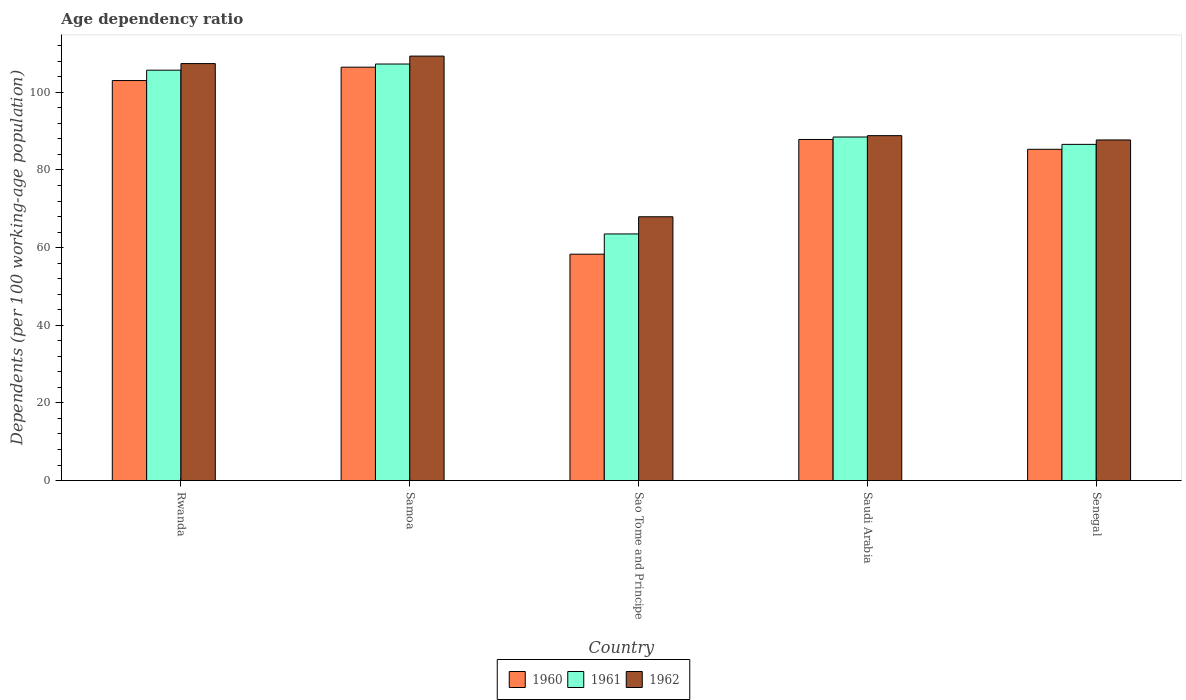How many different coloured bars are there?
Your answer should be very brief. 3. What is the label of the 2nd group of bars from the left?
Provide a succinct answer. Samoa. What is the age dependency ratio in in 1961 in Senegal?
Your answer should be very brief. 86.59. Across all countries, what is the maximum age dependency ratio in in 1960?
Your response must be concise. 106.47. Across all countries, what is the minimum age dependency ratio in in 1961?
Your answer should be compact. 63.52. In which country was the age dependency ratio in in 1961 maximum?
Your answer should be very brief. Samoa. In which country was the age dependency ratio in in 1962 minimum?
Provide a short and direct response. Sao Tome and Principe. What is the total age dependency ratio in in 1961 in the graph?
Keep it short and to the point. 451.57. What is the difference between the age dependency ratio in in 1962 in Saudi Arabia and that in Senegal?
Ensure brevity in your answer.  1.11. What is the difference between the age dependency ratio in in 1962 in Sao Tome and Principe and the age dependency ratio in in 1960 in Samoa?
Provide a succinct answer. -38.53. What is the average age dependency ratio in in 1961 per country?
Offer a very short reply. 90.31. What is the difference between the age dependency ratio in of/in 1962 and age dependency ratio in of/in 1960 in Rwanda?
Provide a succinct answer. 4.37. What is the ratio of the age dependency ratio in in 1962 in Rwanda to that in Saudi Arabia?
Offer a terse response. 1.21. What is the difference between the highest and the second highest age dependency ratio in in 1962?
Keep it short and to the point. -18.56. What is the difference between the highest and the lowest age dependency ratio in in 1962?
Give a very brief answer. 41.38. In how many countries, is the age dependency ratio in in 1962 greater than the average age dependency ratio in in 1962 taken over all countries?
Make the answer very short. 2. How many bars are there?
Your response must be concise. 15. Are all the bars in the graph horizontal?
Your response must be concise. No. How many countries are there in the graph?
Your answer should be compact. 5. Are the values on the major ticks of Y-axis written in scientific E-notation?
Your answer should be very brief. No. Does the graph contain grids?
Offer a very short reply. No. Where does the legend appear in the graph?
Offer a very short reply. Bottom center. How many legend labels are there?
Make the answer very short. 3. What is the title of the graph?
Give a very brief answer. Age dependency ratio. What is the label or title of the X-axis?
Provide a succinct answer. Country. What is the label or title of the Y-axis?
Make the answer very short. Dependents (per 100 working-age population). What is the Dependents (per 100 working-age population) of 1960 in Rwanda?
Provide a succinct answer. 103.02. What is the Dependents (per 100 working-age population) of 1961 in Rwanda?
Provide a succinct answer. 105.69. What is the Dependents (per 100 working-age population) of 1962 in Rwanda?
Provide a short and direct response. 107.39. What is the Dependents (per 100 working-age population) of 1960 in Samoa?
Provide a short and direct response. 106.47. What is the Dependents (per 100 working-age population) of 1961 in Samoa?
Keep it short and to the point. 107.28. What is the Dependents (per 100 working-age population) in 1962 in Samoa?
Ensure brevity in your answer.  109.32. What is the Dependents (per 100 working-age population) in 1960 in Sao Tome and Principe?
Provide a succinct answer. 58.31. What is the Dependents (per 100 working-age population) in 1961 in Sao Tome and Principe?
Give a very brief answer. 63.52. What is the Dependents (per 100 working-age population) of 1962 in Sao Tome and Principe?
Your answer should be very brief. 67.94. What is the Dependents (per 100 working-age population) of 1960 in Saudi Arabia?
Your answer should be very brief. 87.85. What is the Dependents (per 100 working-age population) in 1961 in Saudi Arabia?
Your answer should be compact. 88.48. What is the Dependents (per 100 working-age population) in 1962 in Saudi Arabia?
Your answer should be very brief. 88.83. What is the Dependents (per 100 working-age population) of 1960 in Senegal?
Ensure brevity in your answer.  85.32. What is the Dependents (per 100 working-age population) in 1961 in Senegal?
Keep it short and to the point. 86.59. What is the Dependents (per 100 working-age population) of 1962 in Senegal?
Offer a terse response. 87.72. Across all countries, what is the maximum Dependents (per 100 working-age population) in 1960?
Keep it short and to the point. 106.47. Across all countries, what is the maximum Dependents (per 100 working-age population) in 1961?
Offer a terse response. 107.28. Across all countries, what is the maximum Dependents (per 100 working-age population) in 1962?
Provide a succinct answer. 109.32. Across all countries, what is the minimum Dependents (per 100 working-age population) in 1960?
Keep it short and to the point. 58.31. Across all countries, what is the minimum Dependents (per 100 working-age population) of 1961?
Your response must be concise. 63.52. Across all countries, what is the minimum Dependents (per 100 working-age population) in 1962?
Offer a terse response. 67.94. What is the total Dependents (per 100 working-age population) of 1960 in the graph?
Make the answer very short. 440.96. What is the total Dependents (per 100 working-age population) of 1961 in the graph?
Your response must be concise. 451.57. What is the total Dependents (per 100 working-age population) in 1962 in the graph?
Keep it short and to the point. 461.21. What is the difference between the Dependents (per 100 working-age population) of 1960 in Rwanda and that in Samoa?
Your response must be concise. -3.44. What is the difference between the Dependents (per 100 working-age population) of 1961 in Rwanda and that in Samoa?
Your answer should be very brief. -1.59. What is the difference between the Dependents (per 100 working-age population) in 1962 in Rwanda and that in Samoa?
Give a very brief answer. -1.93. What is the difference between the Dependents (per 100 working-age population) of 1960 in Rwanda and that in Sao Tome and Principe?
Offer a very short reply. 44.72. What is the difference between the Dependents (per 100 working-age population) of 1961 in Rwanda and that in Sao Tome and Principe?
Keep it short and to the point. 42.17. What is the difference between the Dependents (per 100 working-age population) of 1962 in Rwanda and that in Sao Tome and Principe?
Provide a short and direct response. 39.45. What is the difference between the Dependents (per 100 working-age population) in 1960 in Rwanda and that in Saudi Arabia?
Provide a short and direct response. 15.17. What is the difference between the Dependents (per 100 working-age population) of 1961 in Rwanda and that in Saudi Arabia?
Your answer should be very brief. 17.21. What is the difference between the Dependents (per 100 working-age population) of 1962 in Rwanda and that in Saudi Arabia?
Your response must be concise. 18.56. What is the difference between the Dependents (per 100 working-age population) in 1960 in Rwanda and that in Senegal?
Ensure brevity in your answer.  17.7. What is the difference between the Dependents (per 100 working-age population) in 1961 in Rwanda and that in Senegal?
Offer a very short reply. 19.1. What is the difference between the Dependents (per 100 working-age population) in 1962 in Rwanda and that in Senegal?
Offer a very short reply. 19.67. What is the difference between the Dependents (per 100 working-age population) in 1960 in Samoa and that in Sao Tome and Principe?
Make the answer very short. 48.16. What is the difference between the Dependents (per 100 working-age population) of 1961 in Samoa and that in Sao Tome and Principe?
Make the answer very short. 43.76. What is the difference between the Dependents (per 100 working-age population) of 1962 in Samoa and that in Sao Tome and Principe?
Keep it short and to the point. 41.38. What is the difference between the Dependents (per 100 working-age population) in 1960 in Samoa and that in Saudi Arabia?
Give a very brief answer. 18.62. What is the difference between the Dependents (per 100 working-age population) of 1961 in Samoa and that in Saudi Arabia?
Give a very brief answer. 18.8. What is the difference between the Dependents (per 100 working-age population) in 1962 in Samoa and that in Saudi Arabia?
Offer a terse response. 20.49. What is the difference between the Dependents (per 100 working-age population) in 1960 in Samoa and that in Senegal?
Give a very brief answer. 21.15. What is the difference between the Dependents (per 100 working-age population) of 1961 in Samoa and that in Senegal?
Your answer should be very brief. 20.69. What is the difference between the Dependents (per 100 working-age population) in 1962 in Samoa and that in Senegal?
Your answer should be compact. 21.6. What is the difference between the Dependents (per 100 working-age population) in 1960 in Sao Tome and Principe and that in Saudi Arabia?
Your response must be concise. -29.54. What is the difference between the Dependents (per 100 working-age population) in 1961 in Sao Tome and Principe and that in Saudi Arabia?
Provide a short and direct response. -24.97. What is the difference between the Dependents (per 100 working-age population) in 1962 in Sao Tome and Principe and that in Saudi Arabia?
Provide a short and direct response. -20.89. What is the difference between the Dependents (per 100 working-age population) in 1960 in Sao Tome and Principe and that in Senegal?
Make the answer very short. -27.01. What is the difference between the Dependents (per 100 working-age population) of 1961 in Sao Tome and Principe and that in Senegal?
Your answer should be compact. -23.07. What is the difference between the Dependents (per 100 working-age population) in 1962 in Sao Tome and Principe and that in Senegal?
Offer a terse response. -19.78. What is the difference between the Dependents (per 100 working-age population) in 1960 in Saudi Arabia and that in Senegal?
Ensure brevity in your answer.  2.53. What is the difference between the Dependents (per 100 working-age population) in 1961 in Saudi Arabia and that in Senegal?
Provide a succinct answer. 1.9. What is the difference between the Dependents (per 100 working-age population) in 1962 in Saudi Arabia and that in Senegal?
Your answer should be very brief. 1.11. What is the difference between the Dependents (per 100 working-age population) in 1960 in Rwanda and the Dependents (per 100 working-age population) in 1961 in Samoa?
Provide a succinct answer. -4.26. What is the difference between the Dependents (per 100 working-age population) of 1960 in Rwanda and the Dependents (per 100 working-age population) of 1962 in Samoa?
Your response must be concise. -6.3. What is the difference between the Dependents (per 100 working-age population) in 1961 in Rwanda and the Dependents (per 100 working-age population) in 1962 in Samoa?
Provide a succinct answer. -3.63. What is the difference between the Dependents (per 100 working-age population) of 1960 in Rwanda and the Dependents (per 100 working-age population) of 1961 in Sao Tome and Principe?
Your answer should be very brief. 39.5. What is the difference between the Dependents (per 100 working-age population) in 1960 in Rwanda and the Dependents (per 100 working-age population) in 1962 in Sao Tome and Principe?
Your answer should be very brief. 35.08. What is the difference between the Dependents (per 100 working-age population) in 1961 in Rwanda and the Dependents (per 100 working-age population) in 1962 in Sao Tome and Principe?
Ensure brevity in your answer.  37.75. What is the difference between the Dependents (per 100 working-age population) in 1960 in Rwanda and the Dependents (per 100 working-age population) in 1961 in Saudi Arabia?
Offer a very short reply. 14.54. What is the difference between the Dependents (per 100 working-age population) in 1960 in Rwanda and the Dependents (per 100 working-age population) in 1962 in Saudi Arabia?
Offer a terse response. 14.19. What is the difference between the Dependents (per 100 working-age population) of 1961 in Rwanda and the Dependents (per 100 working-age population) of 1962 in Saudi Arabia?
Your answer should be very brief. 16.86. What is the difference between the Dependents (per 100 working-age population) of 1960 in Rwanda and the Dependents (per 100 working-age population) of 1961 in Senegal?
Offer a very short reply. 16.43. What is the difference between the Dependents (per 100 working-age population) of 1960 in Rwanda and the Dependents (per 100 working-age population) of 1962 in Senegal?
Offer a very short reply. 15.3. What is the difference between the Dependents (per 100 working-age population) of 1961 in Rwanda and the Dependents (per 100 working-age population) of 1962 in Senegal?
Give a very brief answer. 17.97. What is the difference between the Dependents (per 100 working-age population) in 1960 in Samoa and the Dependents (per 100 working-age population) in 1961 in Sao Tome and Principe?
Offer a very short reply. 42.95. What is the difference between the Dependents (per 100 working-age population) of 1960 in Samoa and the Dependents (per 100 working-age population) of 1962 in Sao Tome and Principe?
Offer a very short reply. 38.53. What is the difference between the Dependents (per 100 working-age population) in 1961 in Samoa and the Dependents (per 100 working-age population) in 1962 in Sao Tome and Principe?
Your answer should be compact. 39.34. What is the difference between the Dependents (per 100 working-age population) of 1960 in Samoa and the Dependents (per 100 working-age population) of 1961 in Saudi Arabia?
Offer a very short reply. 17.98. What is the difference between the Dependents (per 100 working-age population) of 1960 in Samoa and the Dependents (per 100 working-age population) of 1962 in Saudi Arabia?
Provide a succinct answer. 17.63. What is the difference between the Dependents (per 100 working-age population) in 1961 in Samoa and the Dependents (per 100 working-age population) in 1962 in Saudi Arabia?
Give a very brief answer. 18.45. What is the difference between the Dependents (per 100 working-age population) of 1960 in Samoa and the Dependents (per 100 working-age population) of 1961 in Senegal?
Provide a succinct answer. 19.88. What is the difference between the Dependents (per 100 working-age population) of 1960 in Samoa and the Dependents (per 100 working-age population) of 1962 in Senegal?
Ensure brevity in your answer.  18.75. What is the difference between the Dependents (per 100 working-age population) in 1961 in Samoa and the Dependents (per 100 working-age population) in 1962 in Senegal?
Give a very brief answer. 19.56. What is the difference between the Dependents (per 100 working-age population) of 1960 in Sao Tome and Principe and the Dependents (per 100 working-age population) of 1961 in Saudi Arabia?
Your answer should be compact. -30.18. What is the difference between the Dependents (per 100 working-age population) of 1960 in Sao Tome and Principe and the Dependents (per 100 working-age population) of 1962 in Saudi Arabia?
Offer a very short reply. -30.53. What is the difference between the Dependents (per 100 working-age population) in 1961 in Sao Tome and Principe and the Dependents (per 100 working-age population) in 1962 in Saudi Arabia?
Your answer should be very brief. -25.32. What is the difference between the Dependents (per 100 working-age population) of 1960 in Sao Tome and Principe and the Dependents (per 100 working-age population) of 1961 in Senegal?
Provide a succinct answer. -28.28. What is the difference between the Dependents (per 100 working-age population) in 1960 in Sao Tome and Principe and the Dependents (per 100 working-age population) in 1962 in Senegal?
Offer a very short reply. -29.42. What is the difference between the Dependents (per 100 working-age population) of 1961 in Sao Tome and Principe and the Dependents (per 100 working-age population) of 1962 in Senegal?
Your answer should be compact. -24.2. What is the difference between the Dependents (per 100 working-age population) of 1960 in Saudi Arabia and the Dependents (per 100 working-age population) of 1961 in Senegal?
Offer a terse response. 1.26. What is the difference between the Dependents (per 100 working-age population) in 1960 in Saudi Arabia and the Dependents (per 100 working-age population) in 1962 in Senegal?
Your answer should be compact. 0.13. What is the difference between the Dependents (per 100 working-age population) in 1961 in Saudi Arabia and the Dependents (per 100 working-age population) in 1962 in Senegal?
Make the answer very short. 0.76. What is the average Dependents (per 100 working-age population) in 1960 per country?
Offer a terse response. 88.19. What is the average Dependents (per 100 working-age population) of 1961 per country?
Your response must be concise. 90.31. What is the average Dependents (per 100 working-age population) of 1962 per country?
Offer a very short reply. 92.24. What is the difference between the Dependents (per 100 working-age population) in 1960 and Dependents (per 100 working-age population) in 1961 in Rwanda?
Keep it short and to the point. -2.67. What is the difference between the Dependents (per 100 working-age population) of 1960 and Dependents (per 100 working-age population) of 1962 in Rwanda?
Provide a short and direct response. -4.37. What is the difference between the Dependents (per 100 working-age population) of 1961 and Dependents (per 100 working-age population) of 1962 in Rwanda?
Make the answer very short. -1.7. What is the difference between the Dependents (per 100 working-age population) in 1960 and Dependents (per 100 working-age population) in 1961 in Samoa?
Ensure brevity in your answer.  -0.82. What is the difference between the Dependents (per 100 working-age population) of 1960 and Dependents (per 100 working-age population) of 1962 in Samoa?
Your response must be concise. -2.85. What is the difference between the Dependents (per 100 working-age population) in 1961 and Dependents (per 100 working-age population) in 1962 in Samoa?
Offer a terse response. -2.04. What is the difference between the Dependents (per 100 working-age population) of 1960 and Dependents (per 100 working-age population) of 1961 in Sao Tome and Principe?
Offer a terse response. -5.21. What is the difference between the Dependents (per 100 working-age population) of 1960 and Dependents (per 100 working-age population) of 1962 in Sao Tome and Principe?
Give a very brief answer. -9.63. What is the difference between the Dependents (per 100 working-age population) of 1961 and Dependents (per 100 working-age population) of 1962 in Sao Tome and Principe?
Offer a very short reply. -4.42. What is the difference between the Dependents (per 100 working-age population) in 1960 and Dependents (per 100 working-age population) in 1961 in Saudi Arabia?
Ensure brevity in your answer.  -0.63. What is the difference between the Dependents (per 100 working-age population) of 1960 and Dependents (per 100 working-age population) of 1962 in Saudi Arabia?
Keep it short and to the point. -0.98. What is the difference between the Dependents (per 100 working-age population) of 1961 and Dependents (per 100 working-age population) of 1962 in Saudi Arabia?
Provide a succinct answer. -0.35. What is the difference between the Dependents (per 100 working-age population) of 1960 and Dependents (per 100 working-age population) of 1961 in Senegal?
Your answer should be very brief. -1.27. What is the difference between the Dependents (per 100 working-age population) in 1960 and Dependents (per 100 working-age population) in 1962 in Senegal?
Offer a very short reply. -2.4. What is the difference between the Dependents (per 100 working-age population) in 1961 and Dependents (per 100 working-age population) in 1962 in Senegal?
Give a very brief answer. -1.13. What is the ratio of the Dependents (per 100 working-age population) of 1960 in Rwanda to that in Samoa?
Your answer should be compact. 0.97. What is the ratio of the Dependents (per 100 working-age population) in 1961 in Rwanda to that in Samoa?
Provide a short and direct response. 0.99. What is the ratio of the Dependents (per 100 working-age population) of 1962 in Rwanda to that in Samoa?
Offer a very short reply. 0.98. What is the ratio of the Dependents (per 100 working-age population) in 1960 in Rwanda to that in Sao Tome and Principe?
Your answer should be compact. 1.77. What is the ratio of the Dependents (per 100 working-age population) in 1961 in Rwanda to that in Sao Tome and Principe?
Offer a very short reply. 1.66. What is the ratio of the Dependents (per 100 working-age population) in 1962 in Rwanda to that in Sao Tome and Principe?
Keep it short and to the point. 1.58. What is the ratio of the Dependents (per 100 working-age population) of 1960 in Rwanda to that in Saudi Arabia?
Keep it short and to the point. 1.17. What is the ratio of the Dependents (per 100 working-age population) in 1961 in Rwanda to that in Saudi Arabia?
Provide a short and direct response. 1.19. What is the ratio of the Dependents (per 100 working-age population) in 1962 in Rwanda to that in Saudi Arabia?
Provide a short and direct response. 1.21. What is the ratio of the Dependents (per 100 working-age population) of 1960 in Rwanda to that in Senegal?
Provide a succinct answer. 1.21. What is the ratio of the Dependents (per 100 working-age population) in 1961 in Rwanda to that in Senegal?
Your answer should be compact. 1.22. What is the ratio of the Dependents (per 100 working-age population) of 1962 in Rwanda to that in Senegal?
Offer a very short reply. 1.22. What is the ratio of the Dependents (per 100 working-age population) in 1960 in Samoa to that in Sao Tome and Principe?
Keep it short and to the point. 1.83. What is the ratio of the Dependents (per 100 working-age population) in 1961 in Samoa to that in Sao Tome and Principe?
Provide a succinct answer. 1.69. What is the ratio of the Dependents (per 100 working-age population) of 1962 in Samoa to that in Sao Tome and Principe?
Provide a succinct answer. 1.61. What is the ratio of the Dependents (per 100 working-age population) of 1960 in Samoa to that in Saudi Arabia?
Keep it short and to the point. 1.21. What is the ratio of the Dependents (per 100 working-age population) in 1961 in Samoa to that in Saudi Arabia?
Your response must be concise. 1.21. What is the ratio of the Dependents (per 100 working-age population) of 1962 in Samoa to that in Saudi Arabia?
Make the answer very short. 1.23. What is the ratio of the Dependents (per 100 working-age population) of 1960 in Samoa to that in Senegal?
Your answer should be very brief. 1.25. What is the ratio of the Dependents (per 100 working-age population) in 1961 in Samoa to that in Senegal?
Provide a succinct answer. 1.24. What is the ratio of the Dependents (per 100 working-age population) of 1962 in Samoa to that in Senegal?
Offer a very short reply. 1.25. What is the ratio of the Dependents (per 100 working-age population) of 1960 in Sao Tome and Principe to that in Saudi Arabia?
Your answer should be very brief. 0.66. What is the ratio of the Dependents (per 100 working-age population) in 1961 in Sao Tome and Principe to that in Saudi Arabia?
Offer a terse response. 0.72. What is the ratio of the Dependents (per 100 working-age population) in 1962 in Sao Tome and Principe to that in Saudi Arabia?
Keep it short and to the point. 0.76. What is the ratio of the Dependents (per 100 working-age population) in 1960 in Sao Tome and Principe to that in Senegal?
Give a very brief answer. 0.68. What is the ratio of the Dependents (per 100 working-age population) of 1961 in Sao Tome and Principe to that in Senegal?
Provide a succinct answer. 0.73. What is the ratio of the Dependents (per 100 working-age population) of 1962 in Sao Tome and Principe to that in Senegal?
Provide a short and direct response. 0.77. What is the ratio of the Dependents (per 100 working-age population) in 1960 in Saudi Arabia to that in Senegal?
Keep it short and to the point. 1.03. What is the ratio of the Dependents (per 100 working-age population) in 1961 in Saudi Arabia to that in Senegal?
Offer a terse response. 1.02. What is the ratio of the Dependents (per 100 working-age population) of 1962 in Saudi Arabia to that in Senegal?
Your answer should be compact. 1.01. What is the difference between the highest and the second highest Dependents (per 100 working-age population) in 1960?
Your answer should be very brief. 3.44. What is the difference between the highest and the second highest Dependents (per 100 working-age population) of 1961?
Provide a succinct answer. 1.59. What is the difference between the highest and the second highest Dependents (per 100 working-age population) of 1962?
Your answer should be very brief. 1.93. What is the difference between the highest and the lowest Dependents (per 100 working-age population) in 1960?
Your response must be concise. 48.16. What is the difference between the highest and the lowest Dependents (per 100 working-age population) of 1961?
Give a very brief answer. 43.76. What is the difference between the highest and the lowest Dependents (per 100 working-age population) of 1962?
Your response must be concise. 41.38. 